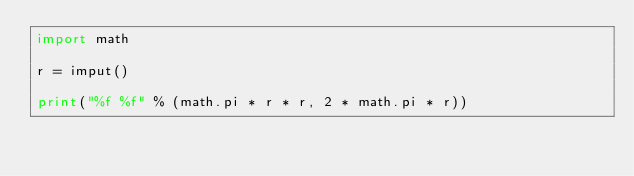<code> <loc_0><loc_0><loc_500><loc_500><_Python_>import math

r = imput()

print("%f %f" % (math.pi * r * r, 2 * math.pi * r))</code> 